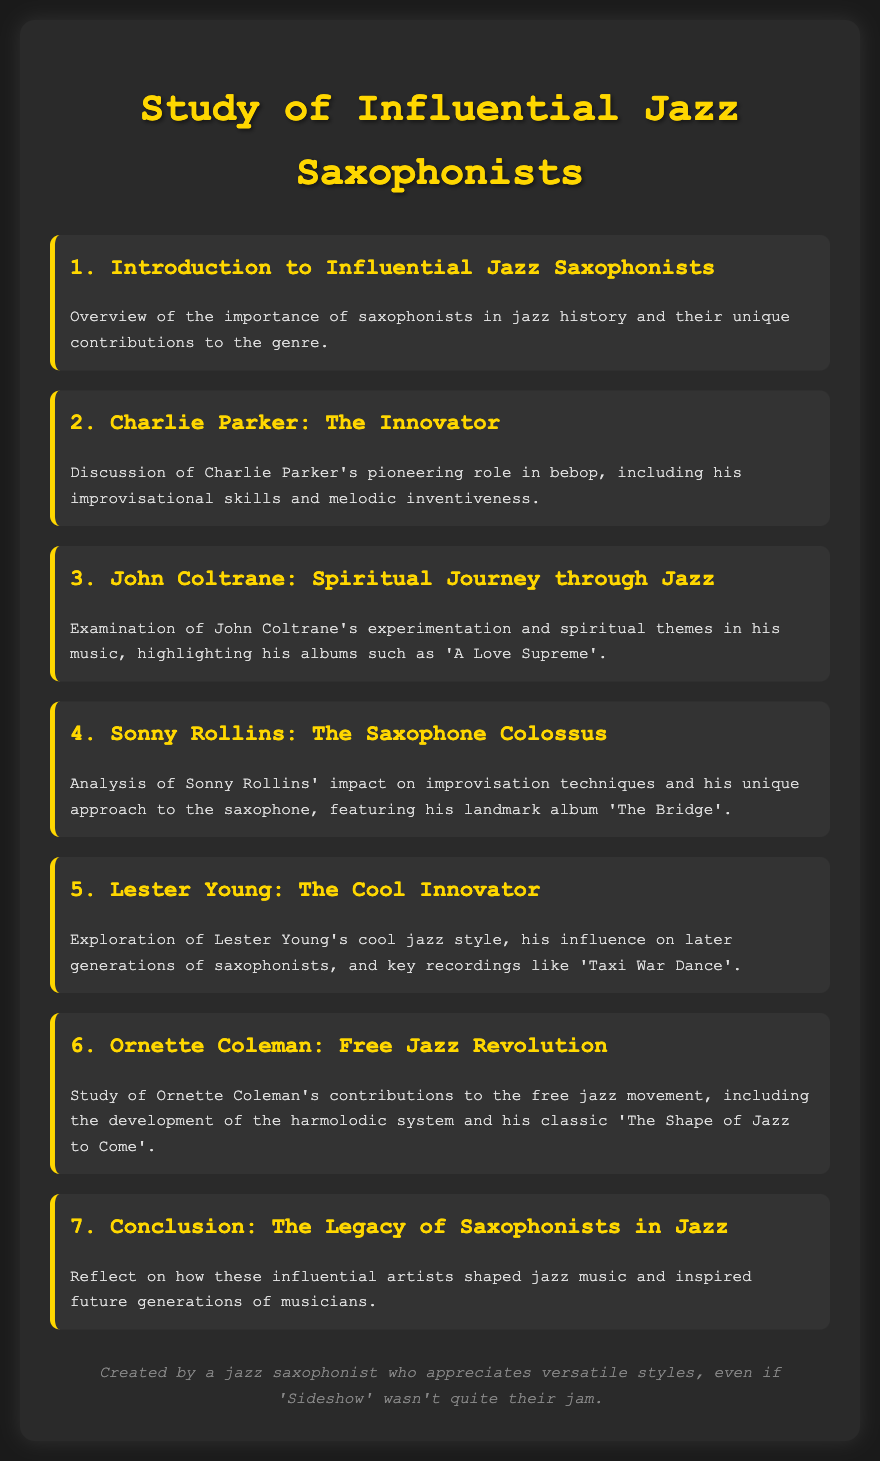What is the title of the document? The title of the document is presented prominently at the top, signaling the subject matter.
Answer: Study of Influential Jazz Saxophonists Who are the saxophonists discussed in the document? The document lists several influential saxophonists in different sections, naming them in the titles.
Answer: Charlie Parker, John Coltrane, Sonny Rollins, Lester Young, Ornette Coleman What musical style is Charlie Parker associated with? Charlie Parker is mentioned as a pioneer of a specific jazz genre in the agenda item about him.
Answer: Bebop What significant album is highlighted in John Coltrane's section? John Coltrane's impact is showcased through a specific album that embodies his spiritual journey.
Answer: A Love Supreme Which saxophonist is referred to as 'The Saxophone Colossus'? The document gives a nickname to a prominent saxophonist based on his influence and contributions.
Answer: Sonny Rollins What jazz concept did Ornette Coleman develop? Ornette Coleman's section mentions a revolutionary music concept that he contributed to the genre.
Answer: Harmolodic system How many saxophonists are discussed in total? By counting the individual sections dedicated to different saxophonists, we can determine the total number mentioned.
Answer: Five What is the conclusion about saxophonists in jazz? The conclusion section reflects on the overall impact of saxophonists, aiming to summarize their influence.
Answer: Legacy 